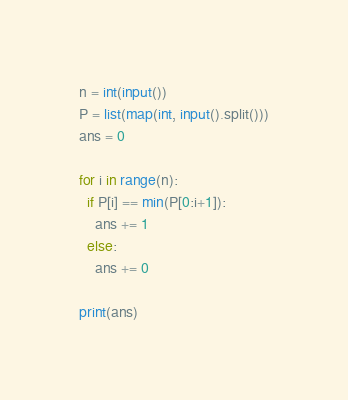Convert code to text. <code><loc_0><loc_0><loc_500><loc_500><_Python_>n = int(input())
P = list(map(int, input().split()))
ans = 0

for i in range(n):
  if P[i] == min(P[0:i+1]):
    ans += 1
  else:
    ans += 0
    
print(ans)</code> 